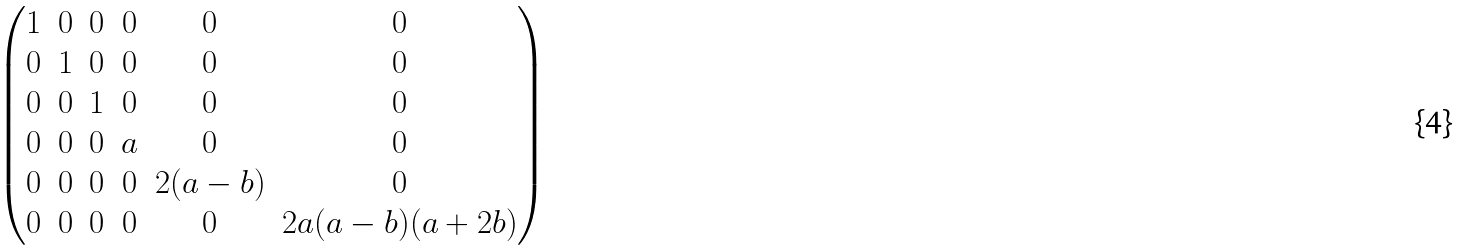<formula> <loc_0><loc_0><loc_500><loc_500>\begin{pmatrix} 1 & 0 & 0 & 0 & 0 & 0 \\ 0 & 1 & 0 & 0 & 0 & 0 \\ 0 & 0 & 1 & 0 & 0 & 0 \\ 0 & 0 & 0 & a & 0 & 0 \\ 0 & 0 & 0 & 0 & 2 ( a - b ) & 0 \\ 0 & 0 & 0 & 0 & 0 & 2 a ( a - b ) ( a + 2 b ) \end{pmatrix}</formula> 